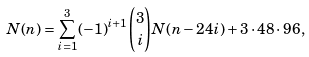Convert formula to latex. <formula><loc_0><loc_0><loc_500><loc_500>N ( n ) = \sum _ { i = 1 } ^ { 3 } ( - 1 ) ^ { i + 1 } \binom { 3 } { i } N ( n - 2 4 i ) + 3 \cdot 4 8 \cdot 9 6 ,</formula> 